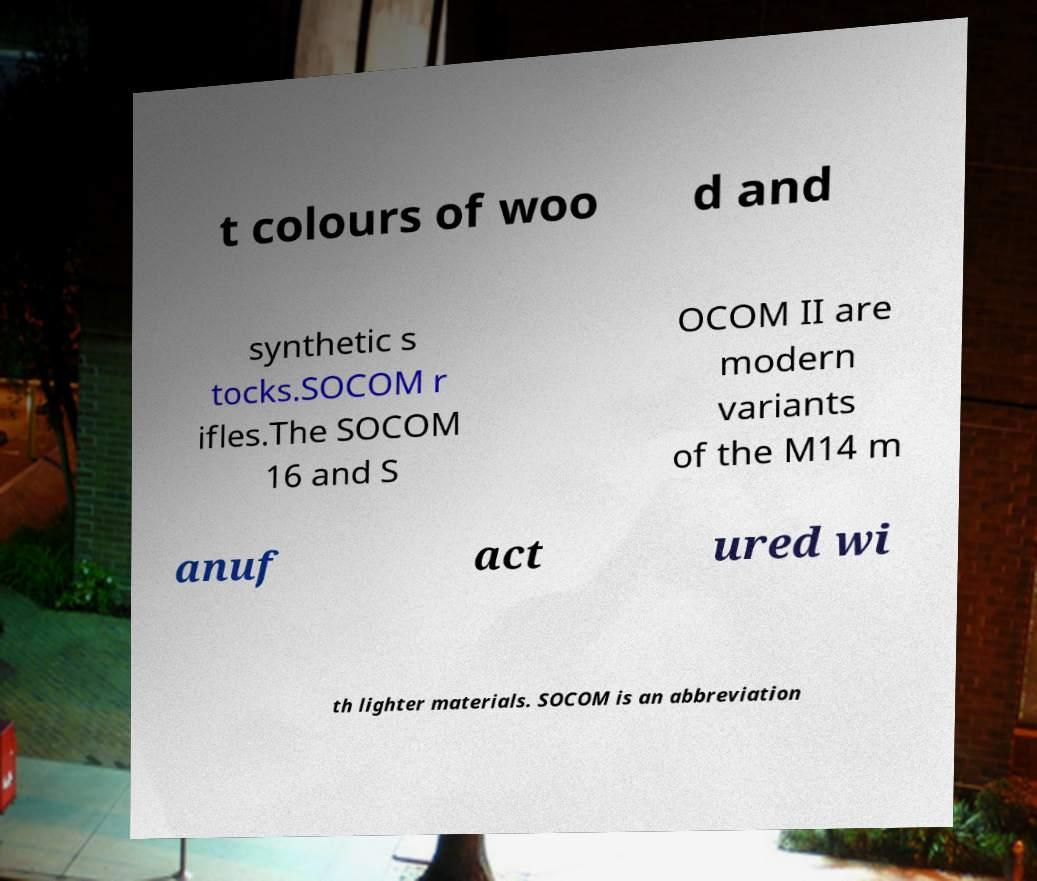Can you accurately transcribe the text from the provided image for me? t colours of woo d and synthetic s tocks.SOCOM r ifles.The SOCOM 16 and S OCOM II are modern variants of the M14 m anuf act ured wi th lighter materials. SOCOM is an abbreviation 